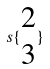<formula> <loc_0><loc_0><loc_500><loc_500>s \{ \begin{matrix} 2 \\ 3 \end{matrix} \}</formula> 